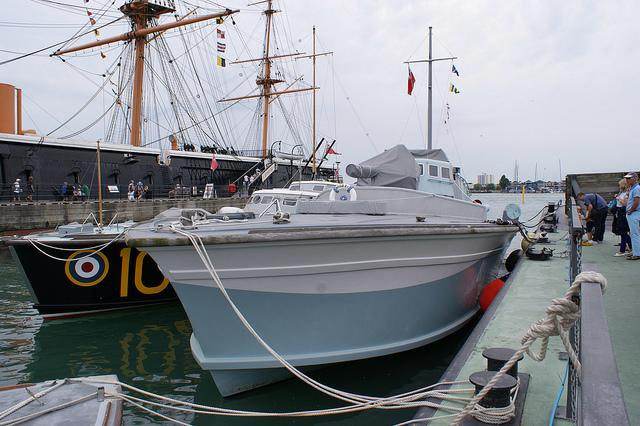What are the people ready to do? sail 